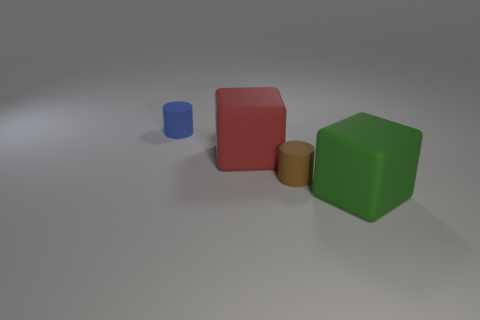Is there a big rubber ball?
Ensure brevity in your answer.  No. Does the large thing that is left of the big green block have the same shape as the small matte thing to the right of the red object?
Offer a terse response. No. Are there any big brown cylinders made of the same material as the small brown thing?
Offer a very short reply. No. Is the material of the cylinder that is in front of the tiny blue matte thing the same as the big green cube?
Your answer should be very brief. Yes. Are there more small blue rubber cylinders that are in front of the green thing than green cubes that are right of the small brown thing?
Give a very brief answer. No. What color is the matte cylinder that is the same size as the blue object?
Keep it short and to the point. Brown. Does the small rubber cylinder in front of the red matte block have the same color as the big matte thing that is right of the big red block?
Provide a short and direct response. No. What is the small thing behind the red rubber object made of?
Your answer should be very brief. Rubber. The other tiny cylinder that is the same material as the small brown cylinder is what color?
Your answer should be very brief. Blue. What number of cubes are the same size as the brown matte cylinder?
Provide a short and direct response. 0. 